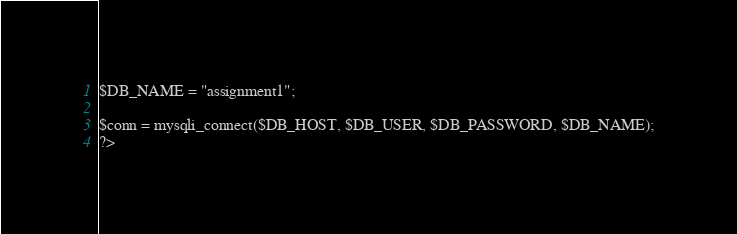<code> <loc_0><loc_0><loc_500><loc_500><_PHP_>$DB_NAME = "assignment1";

$conn = mysqli_connect($DB_HOST, $DB_USER, $DB_PASSWORD, $DB_NAME);
?></code> 